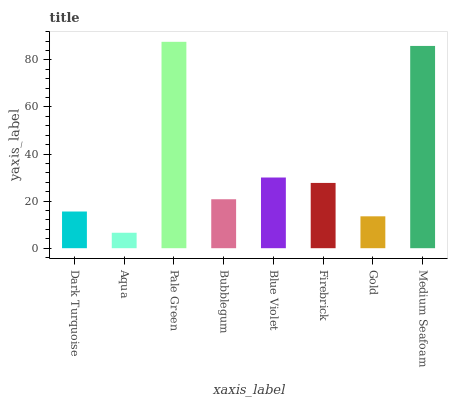Is Pale Green the minimum?
Answer yes or no. No. Is Aqua the maximum?
Answer yes or no. No. Is Pale Green greater than Aqua?
Answer yes or no. Yes. Is Aqua less than Pale Green?
Answer yes or no. Yes. Is Aqua greater than Pale Green?
Answer yes or no. No. Is Pale Green less than Aqua?
Answer yes or no. No. Is Firebrick the high median?
Answer yes or no. Yes. Is Bubblegum the low median?
Answer yes or no. Yes. Is Medium Seafoam the high median?
Answer yes or no. No. Is Firebrick the low median?
Answer yes or no. No. 